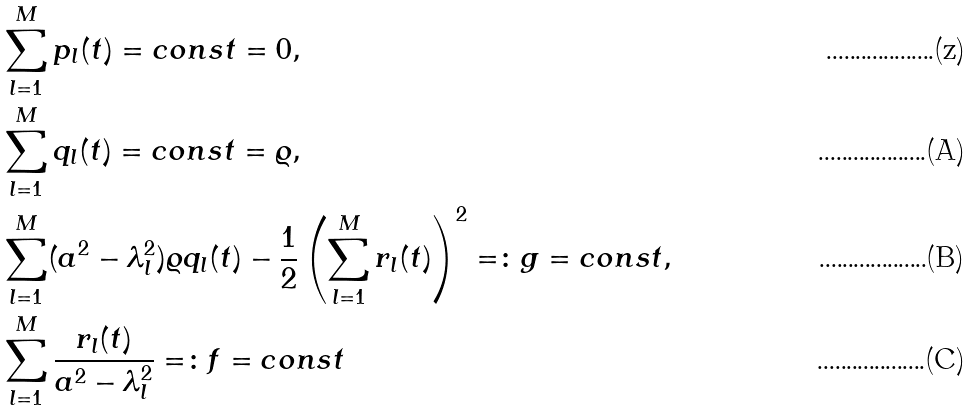Convert formula to latex. <formula><loc_0><loc_0><loc_500><loc_500>& \sum _ { l = 1 } ^ { M } p _ { l } ( t ) = c o n s t = 0 , \\ & \sum _ { l = 1 } ^ { M } q _ { l } ( t ) = c o n s t = \varrho , \\ & \sum _ { l = 1 } ^ { M } ( a ^ { 2 } - \lambda _ { l } ^ { 2 } ) \varrho q _ { l } ( t ) - \frac { 1 } { 2 } \left ( \sum _ { l = 1 } ^ { M } r _ { l } ( t ) \right ) ^ { 2 } = \colon g = c o n s t , \\ & \sum _ { l = 1 } ^ { M } \frac { r _ { l } ( t ) } { a ^ { 2 } - \lambda _ { l } ^ { 2 } } = \colon f = c o n s t</formula> 